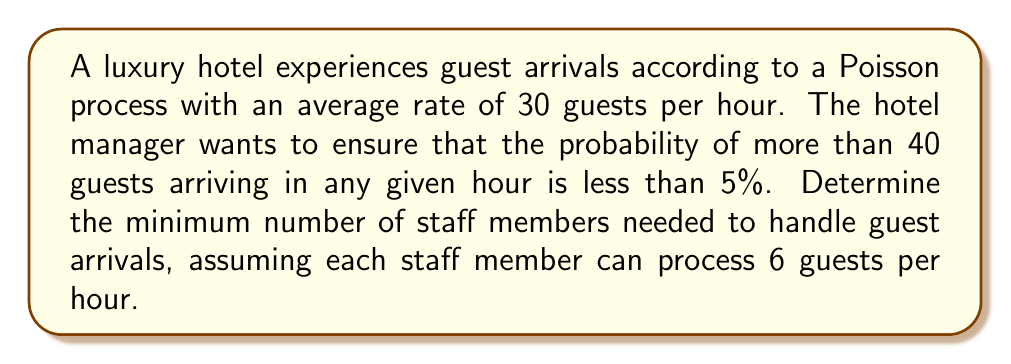Could you help me with this problem? To solve this problem, we'll follow these steps:

1. Calculate the probability of more than 40 guests arriving in an hour
2. Determine the number of guests that can be processed in an hour
3. Find the minimum number of staff needed

Step 1: Calculate the probability of more than 40 guests arriving in an hour

The number of arrivals in a Poisson process follows a Poisson distribution. The probability of more than 40 arrivals in an hour is:

$$P(X > 40) = 1 - P(X \leq 40)$$

Where $X$ is the number of arrivals and $\lambda = 30$ is the average arrival rate.

Using the cumulative distribution function of the Poisson distribution:

$$P(X \leq 40) = e^{-\lambda} \sum_{k=0}^{40} \frac{\lambda^k}{k!}$$

We can calculate this using software or tables, which gives us:

$$P(X \leq 40) \approx 0.9732$$

Therefore,

$$P(X > 40) = 1 - 0.9732 = 0.0268 = 2.68\%$$

This is already less than 5%, so we don't need to adjust the staffing for this criterion.

Step 2: Determine the number of guests that can be processed in an hour

The average arrival rate is 30 guests per hour. To ensure smooth operations, we should be able to process at least this many guests.

Step 3: Find the minimum number of staff needed

Each staff member can process 6 guests per hour. To find the minimum number of staff, we divide the average arrival rate by the processing rate per staff member and round up:

$$\text{Minimum staff} = \left\lceil\frac{30 \text{ guests/hour}}{6 \text{ guests/hour/staff}}\right\rceil = \left\lceil5\right\rceil = 5$$

Therefore, the hotel needs a minimum of 5 staff members to handle the average guest arrival rate.
Answer: The minimum number of staff members needed is 5. 